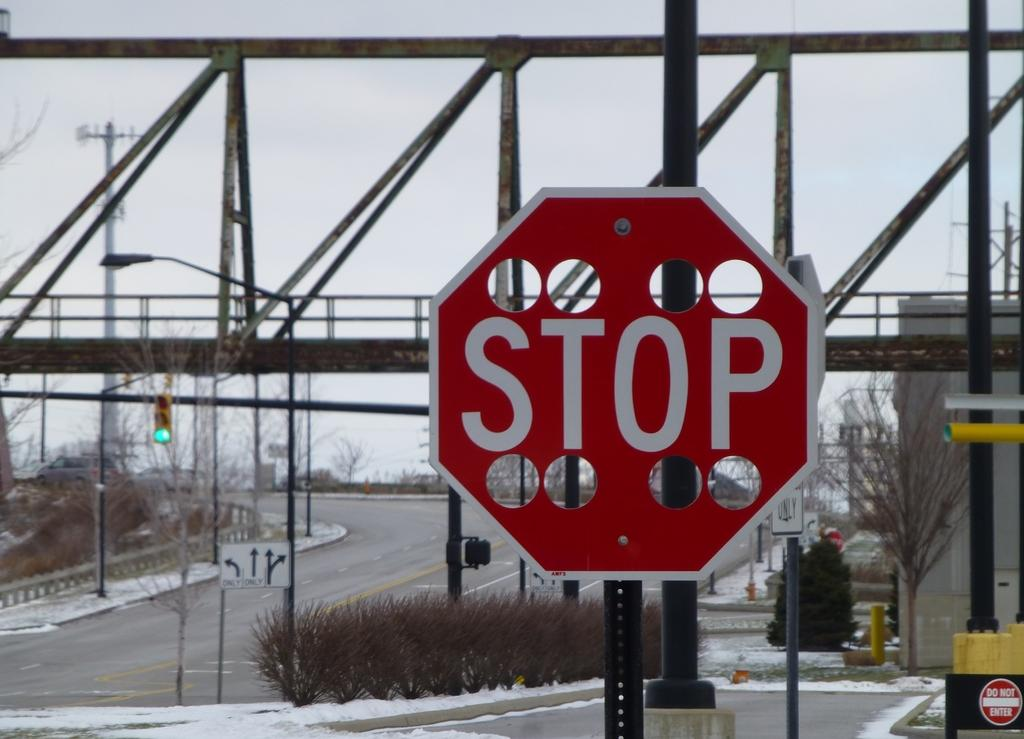<image>
Relay a brief, clear account of the picture shown. A stop sign stands in front of a Do Not Enter sign in the background. 